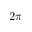<formula> <loc_0><loc_0><loc_500><loc_500>2 \pi</formula> 